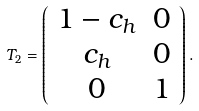<formula> <loc_0><loc_0><loc_500><loc_500>T _ { 2 } = \left ( \begin{array} { c c } 1 - c _ { h } & 0 \\ c _ { h } & 0 \\ 0 & 1 \\ \end{array} \right ) .</formula> 